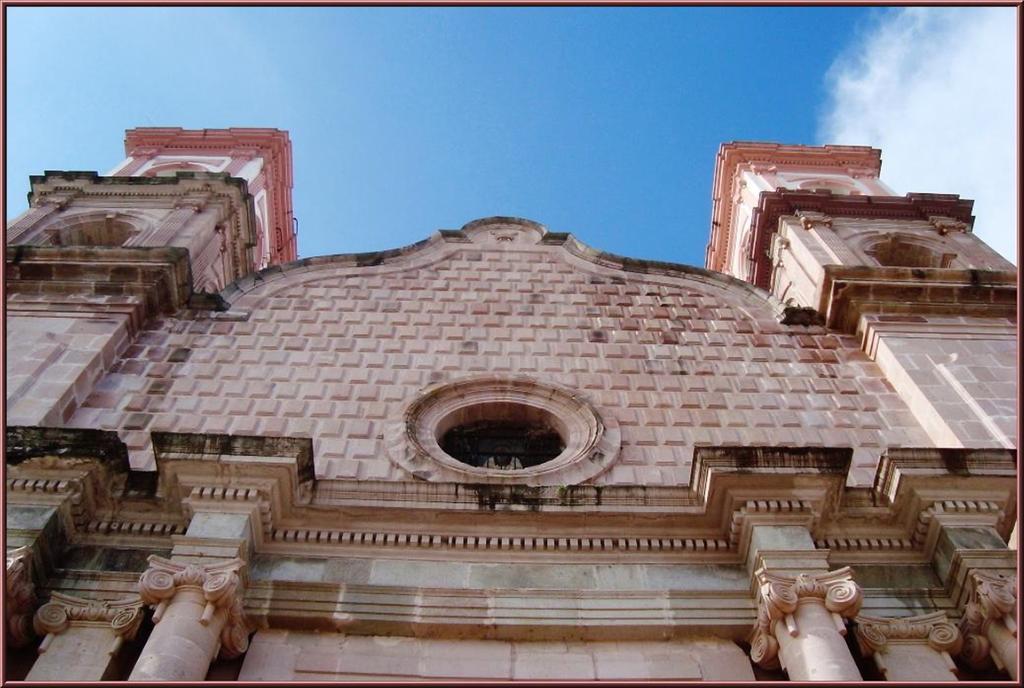How would you summarize this image in a sentence or two? In this image we can see a building. At the top of the image there is sky. 